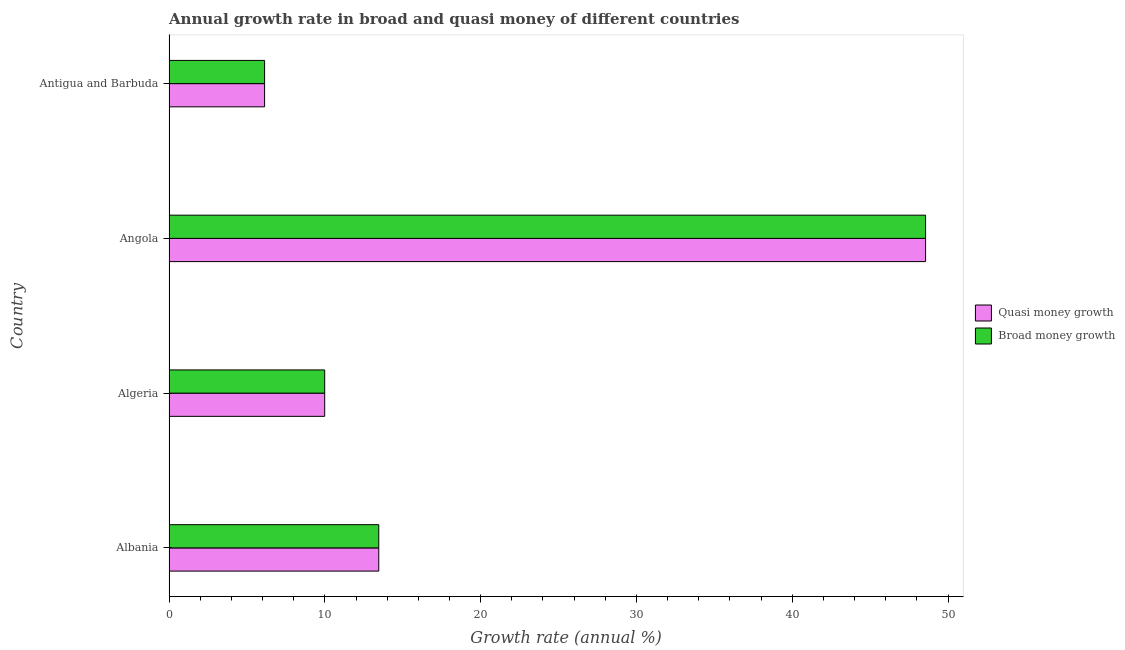How many different coloured bars are there?
Ensure brevity in your answer.  2. How many groups of bars are there?
Your response must be concise. 4. Are the number of bars on each tick of the Y-axis equal?
Make the answer very short. Yes. What is the label of the 1st group of bars from the top?
Your response must be concise. Antigua and Barbuda. What is the annual growth rate in broad money in Antigua and Barbuda?
Keep it short and to the point. 6.13. Across all countries, what is the maximum annual growth rate in quasi money?
Keep it short and to the point. 48.55. Across all countries, what is the minimum annual growth rate in broad money?
Your answer should be compact. 6.13. In which country was the annual growth rate in broad money maximum?
Your answer should be very brief. Angola. In which country was the annual growth rate in quasi money minimum?
Provide a short and direct response. Antigua and Barbuda. What is the total annual growth rate in quasi money in the graph?
Ensure brevity in your answer.  78.14. What is the difference between the annual growth rate in quasi money in Algeria and that in Antigua and Barbuda?
Ensure brevity in your answer.  3.86. What is the difference between the annual growth rate in broad money in Albania and the annual growth rate in quasi money in Algeria?
Offer a very short reply. 3.47. What is the average annual growth rate in broad money per country?
Offer a terse response. 19.54. In how many countries, is the annual growth rate in broad money greater than 40 %?
Ensure brevity in your answer.  1. What is the ratio of the annual growth rate in quasi money in Algeria to that in Angola?
Provide a short and direct response. 0.21. Is the annual growth rate in quasi money in Albania less than that in Antigua and Barbuda?
Give a very brief answer. No. What is the difference between the highest and the second highest annual growth rate in broad money?
Make the answer very short. 35.09. What is the difference between the highest and the lowest annual growth rate in broad money?
Provide a succinct answer. 42.42. In how many countries, is the annual growth rate in quasi money greater than the average annual growth rate in quasi money taken over all countries?
Keep it short and to the point. 1. What does the 2nd bar from the top in Algeria represents?
Give a very brief answer. Quasi money growth. What does the 1st bar from the bottom in Algeria represents?
Make the answer very short. Quasi money growth. Are all the bars in the graph horizontal?
Your answer should be compact. Yes. What is the difference between two consecutive major ticks on the X-axis?
Keep it short and to the point. 10. Does the graph contain grids?
Your response must be concise. No. How are the legend labels stacked?
Give a very brief answer. Vertical. What is the title of the graph?
Make the answer very short. Annual growth rate in broad and quasi money of different countries. Does "Ages 15-24" appear as one of the legend labels in the graph?
Provide a succinct answer. No. What is the label or title of the X-axis?
Make the answer very short. Growth rate (annual %). What is the Growth rate (annual %) of Quasi money growth in Albania?
Ensure brevity in your answer.  13.46. What is the Growth rate (annual %) in Broad money growth in Albania?
Offer a terse response. 13.46. What is the Growth rate (annual %) of Quasi money growth in Algeria?
Your answer should be very brief. 9.99. What is the Growth rate (annual %) of Broad money growth in Algeria?
Your response must be concise. 9.99. What is the Growth rate (annual %) of Quasi money growth in Angola?
Your answer should be very brief. 48.55. What is the Growth rate (annual %) of Broad money growth in Angola?
Your response must be concise. 48.55. What is the Growth rate (annual %) of Quasi money growth in Antigua and Barbuda?
Offer a terse response. 6.13. What is the Growth rate (annual %) in Broad money growth in Antigua and Barbuda?
Your answer should be very brief. 6.13. Across all countries, what is the maximum Growth rate (annual %) of Quasi money growth?
Your answer should be compact. 48.55. Across all countries, what is the maximum Growth rate (annual %) in Broad money growth?
Your answer should be very brief. 48.55. Across all countries, what is the minimum Growth rate (annual %) of Quasi money growth?
Give a very brief answer. 6.13. Across all countries, what is the minimum Growth rate (annual %) of Broad money growth?
Make the answer very short. 6.13. What is the total Growth rate (annual %) in Quasi money growth in the graph?
Your answer should be compact. 78.14. What is the total Growth rate (annual %) in Broad money growth in the graph?
Ensure brevity in your answer.  78.14. What is the difference between the Growth rate (annual %) in Quasi money growth in Albania and that in Algeria?
Give a very brief answer. 3.47. What is the difference between the Growth rate (annual %) of Broad money growth in Albania and that in Algeria?
Offer a terse response. 3.47. What is the difference between the Growth rate (annual %) in Quasi money growth in Albania and that in Angola?
Keep it short and to the point. -35.09. What is the difference between the Growth rate (annual %) in Broad money growth in Albania and that in Angola?
Give a very brief answer. -35.09. What is the difference between the Growth rate (annual %) of Quasi money growth in Albania and that in Antigua and Barbuda?
Make the answer very short. 7.33. What is the difference between the Growth rate (annual %) in Broad money growth in Albania and that in Antigua and Barbuda?
Give a very brief answer. 7.33. What is the difference between the Growth rate (annual %) of Quasi money growth in Algeria and that in Angola?
Offer a very short reply. -38.56. What is the difference between the Growth rate (annual %) in Broad money growth in Algeria and that in Angola?
Give a very brief answer. -38.56. What is the difference between the Growth rate (annual %) of Quasi money growth in Algeria and that in Antigua and Barbuda?
Your response must be concise. 3.86. What is the difference between the Growth rate (annual %) in Broad money growth in Algeria and that in Antigua and Barbuda?
Your response must be concise. 3.86. What is the difference between the Growth rate (annual %) in Quasi money growth in Angola and that in Antigua and Barbuda?
Ensure brevity in your answer.  42.42. What is the difference between the Growth rate (annual %) in Broad money growth in Angola and that in Antigua and Barbuda?
Offer a terse response. 42.42. What is the difference between the Growth rate (annual %) of Quasi money growth in Albania and the Growth rate (annual %) of Broad money growth in Algeria?
Make the answer very short. 3.47. What is the difference between the Growth rate (annual %) in Quasi money growth in Albania and the Growth rate (annual %) in Broad money growth in Angola?
Ensure brevity in your answer.  -35.09. What is the difference between the Growth rate (annual %) of Quasi money growth in Albania and the Growth rate (annual %) of Broad money growth in Antigua and Barbuda?
Your response must be concise. 7.33. What is the difference between the Growth rate (annual %) in Quasi money growth in Algeria and the Growth rate (annual %) in Broad money growth in Angola?
Your response must be concise. -38.56. What is the difference between the Growth rate (annual %) of Quasi money growth in Algeria and the Growth rate (annual %) of Broad money growth in Antigua and Barbuda?
Provide a short and direct response. 3.86. What is the difference between the Growth rate (annual %) in Quasi money growth in Angola and the Growth rate (annual %) in Broad money growth in Antigua and Barbuda?
Offer a terse response. 42.42. What is the average Growth rate (annual %) in Quasi money growth per country?
Keep it short and to the point. 19.53. What is the average Growth rate (annual %) of Broad money growth per country?
Keep it short and to the point. 19.53. What is the difference between the Growth rate (annual %) of Quasi money growth and Growth rate (annual %) of Broad money growth in Algeria?
Your answer should be very brief. 0. What is the difference between the Growth rate (annual %) of Quasi money growth and Growth rate (annual %) of Broad money growth in Angola?
Make the answer very short. 0. What is the ratio of the Growth rate (annual %) in Quasi money growth in Albania to that in Algeria?
Offer a terse response. 1.35. What is the ratio of the Growth rate (annual %) of Broad money growth in Albania to that in Algeria?
Provide a succinct answer. 1.35. What is the ratio of the Growth rate (annual %) of Quasi money growth in Albania to that in Angola?
Provide a succinct answer. 0.28. What is the ratio of the Growth rate (annual %) in Broad money growth in Albania to that in Angola?
Provide a succinct answer. 0.28. What is the ratio of the Growth rate (annual %) of Quasi money growth in Albania to that in Antigua and Barbuda?
Your answer should be very brief. 2.19. What is the ratio of the Growth rate (annual %) in Broad money growth in Albania to that in Antigua and Barbuda?
Ensure brevity in your answer.  2.19. What is the ratio of the Growth rate (annual %) of Quasi money growth in Algeria to that in Angola?
Ensure brevity in your answer.  0.21. What is the ratio of the Growth rate (annual %) of Broad money growth in Algeria to that in Angola?
Keep it short and to the point. 0.21. What is the ratio of the Growth rate (annual %) of Quasi money growth in Algeria to that in Antigua and Barbuda?
Your answer should be very brief. 1.63. What is the ratio of the Growth rate (annual %) of Broad money growth in Algeria to that in Antigua and Barbuda?
Give a very brief answer. 1.63. What is the ratio of the Growth rate (annual %) of Quasi money growth in Angola to that in Antigua and Barbuda?
Your answer should be very brief. 7.91. What is the ratio of the Growth rate (annual %) in Broad money growth in Angola to that in Antigua and Barbuda?
Your response must be concise. 7.91. What is the difference between the highest and the second highest Growth rate (annual %) in Quasi money growth?
Provide a succinct answer. 35.09. What is the difference between the highest and the second highest Growth rate (annual %) of Broad money growth?
Offer a terse response. 35.09. What is the difference between the highest and the lowest Growth rate (annual %) in Quasi money growth?
Make the answer very short. 42.42. What is the difference between the highest and the lowest Growth rate (annual %) of Broad money growth?
Your response must be concise. 42.42. 